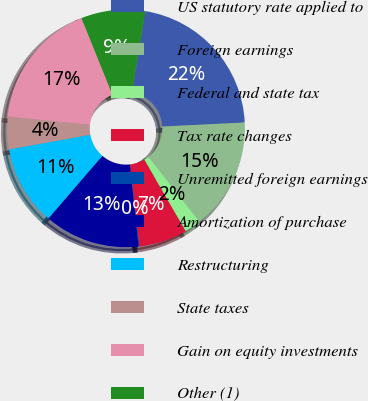<chart> <loc_0><loc_0><loc_500><loc_500><pie_chart><fcel>US statutory rate applied to<fcel>Foreign earnings<fcel>Federal and state tax<fcel>Tax rate changes<fcel>Unremitted foreign earnings<fcel>Amortization of purchase<fcel>Restructuring<fcel>State taxes<fcel>Gain on equity investments<fcel>Other (1)<nl><fcel>21.61%<fcel>15.16%<fcel>2.26%<fcel>6.56%<fcel>0.11%<fcel>13.01%<fcel>10.86%<fcel>4.41%<fcel>17.31%<fcel>8.71%<nl></chart> 